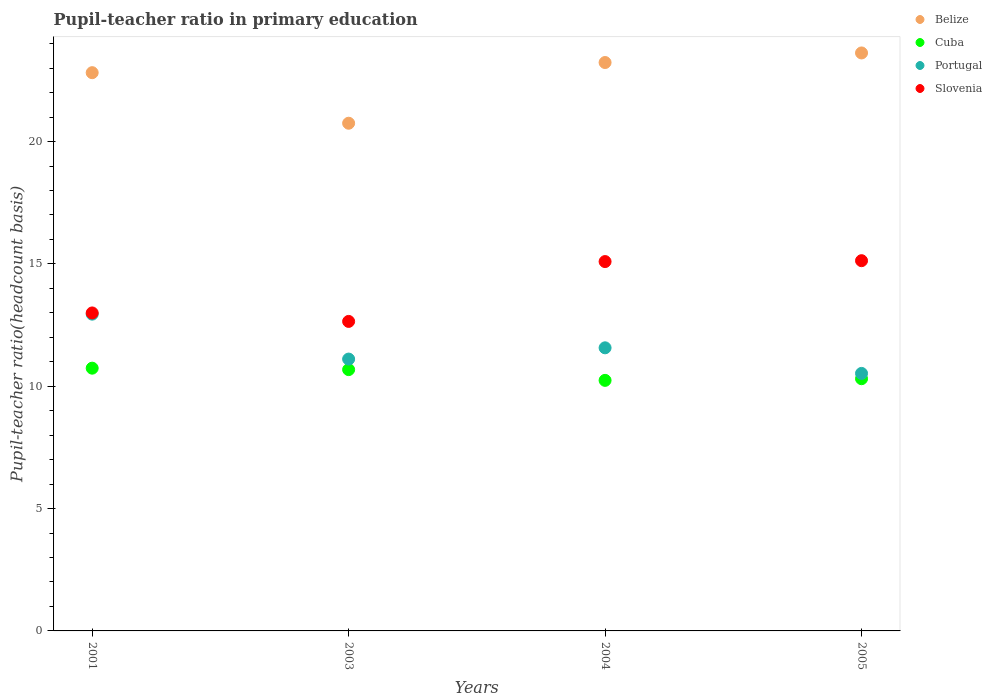How many different coloured dotlines are there?
Give a very brief answer. 4. Is the number of dotlines equal to the number of legend labels?
Keep it short and to the point. Yes. What is the pupil-teacher ratio in primary education in Belize in 2004?
Your answer should be very brief. 23.23. Across all years, what is the maximum pupil-teacher ratio in primary education in Slovenia?
Provide a short and direct response. 15.13. Across all years, what is the minimum pupil-teacher ratio in primary education in Belize?
Keep it short and to the point. 20.75. In which year was the pupil-teacher ratio in primary education in Belize minimum?
Provide a succinct answer. 2003. What is the total pupil-teacher ratio in primary education in Cuba in the graph?
Ensure brevity in your answer.  41.97. What is the difference between the pupil-teacher ratio in primary education in Slovenia in 2001 and that in 2005?
Give a very brief answer. -2.14. What is the difference between the pupil-teacher ratio in primary education in Slovenia in 2004 and the pupil-teacher ratio in primary education in Portugal in 2003?
Make the answer very short. 3.99. What is the average pupil-teacher ratio in primary education in Slovenia per year?
Your answer should be compact. 13.97. In the year 2005, what is the difference between the pupil-teacher ratio in primary education in Belize and pupil-teacher ratio in primary education in Cuba?
Make the answer very short. 13.32. In how many years, is the pupil-teacher ratio in primary education in Portugal greater than 8?
Offer a terse response. 4. What is the ratio of the pupil-teacher ratio in primary education in Cuba in 2003 to that in 2005?
Your response must be concise. 1.04. Is the pupil-teacher ratio in primary education in Belize in 2001 less than that in 2003?
Make the answer very short. No. Is the difference between the pupil-teacher ratio in primary education in Belize in 2001 and 2005 greater than the difference between the pupil-teacher ratio in primary education in Cuba in 2001 and 2005?
Provide a short and direct response. No. What is the difference between the highest and the second highest pupil-teacher ratio in primary education in Portugal?
Your response must be concise. 1.38. What is the difference between the highest and the lowest pupil-teacher ratio in primary education in Slovenia?
Provide a short and direct response. 2.48. In how many years, is the pupil-teacher ratio in primary education in Portugal greater than the average pupil-teacher ratio in primary education in Portugal taken over all years?
Your answer should be compact. 2. Is the sum of the pupil-teacher ratio in primary education in Belize in 2001 and 2005 greater than the maximum pupil-teacher ratio in primary education in Portugal across all years?
Your response must be concise. Yes. Is it the case that in every year, the sum of the pupil-teacher ratio in primary education in Cuba and pupil-teacher ratio in primary education in Belize  is greater than the sum of pupil-teacher ratio in primary education in Portugal and pupil-teacher ratio in primary education in Slovenia?
Provide a short and direct response. Yes. Is it the case that in every year, the sum of the pupil-teacher ratio in primary education in Slovenia and pupil-teacher ratio in primary education in Cuba  is greater than the pupil-teacher ratio in primary education in Belize?
Provide a short and direct response. Yes. Does the pupil-teacher ratio in primary education in Portugal monotonically increase over the years?
Your response must be concise. No. How many dotlines are there?
Provide a short and direct response. 4. Does the graph contain grids?
Your answer should be compact. No. Where does the legend appear in the graph?
Offer a terse response. Top right. What is the title of the graph?
Offer a very short reply. Pupil-teacher ratio in primary education. Does "Middle income" appear as one of the legend labels in the graph?
Keep it short and to the point. No. What is the label or title of the Y-axis?
Ensure brevity in your answer.  Pupil-teacher ratio(headcount basis). What is the Pupil-teacher ratio(headcount basis) of Belize in 2001?
Give a very brief answer. 22.82. What is the Pupil-teacher ratio(headcount basis) in Cuba in 2001?
Offer a terse response. 10.74. What is the Pupil-teacher ratio(headcount basis) in Portugal in 2001?
Give a very brief answer. 12.95. What is the Pupil-teacher ratio(headcount basis) of Slovenia in 2001?
Provide a short and direct response. 13. What is the Pupil-teacher ratio(headcount basis) in Belize in 2003?
Offer a terse response. 20.75. What is the Pupil-teacher ratio(headcount basis) in Cuba in 2003?
Offer a very short reply. 10.68. What is the Pupil-teacher ratio(headcount basis) of Portugal in 2003?
Your answer should be very brief. 11.11. What is the Pupil-teacher ratio(headcount basis) of Slovenia in 2003?
Your response must be concise. 12.65. What is the Pupil-teacher ratio(headcount basis) in Belize in 2004?
Ensure brevity in your answer.  23.23. What is the Pupil-teacher ratio(headcount basis) of Cuba in 2004?
Provide a short and direct response. 10.24. What is the Pupil-teacher ratio(headcount basis) in Portugal in 2004?
Your response must be concise. 11.57. What is the Pupil-teacher ratio(headcount basis) of Slovenia in 2004?
Offer a terse response. 15.1. What is the Pupil-teacher ratio(headcount basis) in Belize in 2005?
Offer a very short reply. 23.62. What is the Pupil-teacher ratio(headcount basis) in Cuba in 2005?
Your answer should be very brief. 10.31. What is the Pupil-teacher ratio(headcount basis) of Portugal in 2005?
Offer a very short reply. 10.53. What is the Pupil-teacher ratio(headcount basis) in Slovenia in 2005?
Your response must be concise. 15.13. Across all years, what is the maximum Pupil-teacher ratio(headcount basis) in Belize?
Ensure brevity in your answer.  23.62. Across all years, what is the maximum Pupil-teacher ratio(headcount basis) of Cuba?
Your answer should be compact. 10.74. Across all years, what is the maximum Pupil-teacher ratio(headcount basis) in Portugal?
Your answer should be compact. 12.95. Across all years, what is the maximum Pupil-teacher ratio(headcount basis) in Slovenia?
Ensure brevity in your answer.  15.13. Across all years, what is the minimum Pupil-teacher ratio(headcount basis) of Belize?
Your answer should be compact. 20.75. Across all years, what is the minimum Pupil-teacher ratio(headcount basis) of Cuba?
Provide a succinct answer. 10.24. Across all years, what is the minimum Pupil-teacher ratio(headcount basis) in Portugal?
Keep it short and to the point. 10.53. Across all years, what is the minimum Pupil-teacher ratio(headcount basis) in Slovenia?
Provide a succinct answer. 12.65. What is the total Pupil-teacher ratio(headcount basis) in Belize in the graph?
Ensure brevity in your answer.  90.42. What is the total Pupil-teacher ratio(headcount basis) in Cuba in the graph?
Offer a very short reply. 41.97. What is the total Pupil-teacher ratio(headcount basis) in Portugal in the graph?
Your answer should be compact. 46.15. What is the total Pupil-teacher ratio(headcount basis) of Slovenia in the graph?
Keep it short and to the point. 55.88. What is the difference between the Pupil-teacher ratio(headcount basis) in Belize in 2001 and that in 2003?
Provide a short and direct response. 2.07. What is the difference between the Pupil-teacher ratio(headcount basis) of Cuba in 2001 and that in 2003?
Keep it short and to the point. 0.06. What is the difference between the Pupil-teacher ratio(headcount basis) of Portugal in 2001 and that in 2003?
Keep it short and to the point. 1.84. What is the difference between the Pupil-teacher ratio(headcount basis) in Slovenia in 2001 and that in 2003?
Your answer should be compact. 0.35. What is the difference between the Pupil-teacher ratio(headcount basis) in Belize in 2001 and that in 2004?
Your answer should be very brief. -0.41. What is the difference between the Pupil-teacher ratio(headcount basis) of Cuba in 2001 and that in 2004?
Offer a very short reply. 0.5. What is the difference between the Pupil-teacher ratio(headcount basis) of Portugal in 2001 and that in 2004?
Offer a terse response. 1.38. What is the difference between the Pupil-teacher ratio(headcount basis) in Slovenia in 2001 and that in 2004?
Make the answer very short. -2.1. What is the difference between the Pupil-teacher ratio(headcount basis) of Belize in 2001 and that in 2005?
Ensure brevity in your answer.  -0.81. What is the difference between the Pupil-teacher ratio(headcount basis) of Cuba in 2001 and that in 2005?
Your response must be concise. 0.43. What is the difference between the Pupil-teacher ratio(headcount basis) of Portugal in 2001 and that in 2005?
Offer a terse response. 2.42. What is the difference between the Pupil-teacher ratio(headcount basis) in Slovenia in 2001 and that in 2005?
Provide a short and direct response. -2.14. What is the difference between the Pupil-teacher ratio(headcount basis) of Belize in 2003 and that in 2004?
Your answer should be very brief. -2.48. What is the difference between the Pupil-teacher ratio(headcount basis) in Cuba in 2003 and that in 2004?
Provide a short and direct response. 0.44. What is the difference between the Pupil-teacher ratio(headcount basis) in Portugal in 2003 and that in 2004?
Your answer should be very brief. -0.46. What is the difference between the Pupil-teacher ratio(headcount basis) of Slovenia in 2003 and that in 2004?
Offer a very short reply. -2.45. What is the difference between the Pupil-teacher ratio(headcount basis) in Belize in 2003 and that in 2005?
Give a very brief answer. -2.87. What is the difference between the Pupil-teacher ratio(headcount basis) in Cuba in 2003 and that in 2005?
Offer a terse response. 0.37. What is the difference between the Pupil-teacher ratio(headcount basis) of Portugal in 2003 and that in 2005?
Provide a succinct answer. 0.59. What is the difference between the Pupil-teacher ratio(headcount basis) in Slovenia in 2003 and that in 2005?
Give a very brief answer. -2.48. What is the difference between the Pupil-teacher ratio(headcount basis) of Belize in 2004 and that in 2005?
Provide a succinct answer. -0.39. What is the difference between the Pupil-teacher ratio(headcount basis) of Cuba in 2004 and that in 2005?
Your answer should be very brief. -0.07. What is the difference between the Pupil-teacher ratio(headcount basis) in Portugal in 2004 and that in 2005?
Offer a very short reply. 1.05. What is the difference between the Pupil-teacher ratio(headcount basis) of Slovenia in 2004 and that in 2005?
Offer a very short reply. -0.04. What is the difference between the Pupil-teacher ratio(headcount basis) in Belize in 2001 and the Pupil-teacher ratio(headcount basis) in Cuba in 2003?
Make the answer very short. 12.14. What is the difference between the Pupil-teacher ratio(headcount basis) in Belize in 2001 and the Pupil-teacher ratio(headcount basis) in Portugal in 2003?
Offer a very short reply. 11.71. What is the difference between the Pupil-teacher ratio(headcount basis) in Belize in 2001 and the Pupil-teacher ratio(headcount basis) in Slovenia in 2003?
Give a very brief answer. 10.17. What is the difference between the Pupil-teacher ratio(headcount basis) of Cuba in 2001 and the Pupil-teacher ratio(headcount basis) of Portugal in 2003?
Your answer should be compact. -0.37. What is the difference between the Pupil-teacher ratio(headcount basis) in Cuba in 2001 and the Pupil-teacher ratio(headcount basis) in Slovenia in 2003?
Offer a very short reply. -1.91. What is the difference between the Pupil-teacher ratio(headcount basis) of Portugal in 2001 and the Pupil-teacher ratio(headcount basis) of Slovenia in 2003?
Keep it short and to the point. 0.3. What is the difference between the Pupil-teacher ratio(headcount basis) in Belize in 2001 and the Pupil-teacher ratio(headcount basis) in Cuba in 2004?
Provide a short and direct response. 12.58. What is the difference between the Pupil-teacher ratio(headcount basis) in Belize in 2001 and the Pupil-teacher ratio(headcount basis) in Portugal in 2004?
Offer a very short reply. 11.25. What is the difference between the Pupil-teacher ratio(headcount basis) in Belize in 2001 and the Pupil-teacher ratio(headcount basis) in Slovenia in 2004?
Provide a short and direct response. 7.72. What is the difference between the Pupil-teacher ratio(headcount basis) of Cuba in 2001 and the Pupil-teacher ratio(headcount basis) of Portugal in 2004?
Your response must be concise. -0.83. What is the difference between the Pupil-teacher ratio(headcount basis) in Cuba in 2001 and the Pupil-teacher ratio(headcount basis) in Slovenia in 2004?
Your answer should be compact. -4.36. What is the difference between the Pupil-teacher ratio(headcount basis) of Portugal in 2001 and the Pupil-teacher ratio(headcount basis) of Slovenia in 2004?
Provide a succinct answer. -2.15. What is the difference between the Pupil-teacher ratio(headcount basis) in Belize in 2001 and the Pupil-teacher ratio(headcount basis) in Cuba in 2005?
Make the answer very short. 12.51. What is the difference between the Pupil-teacher ratio(headcount basis) of Belize in 2001 and the Pupil-teacher ratio(headcount basis) of Portugal in 2005?
Give a very brief answer. 12.29. What is the difference between the Pupil-teacher ratio(headcount basis) in Belize in 2001 and the Pupil-teacher ratio(headcount basis) in Slovenia in 2005?
Offer a terse response. 7.68. What is the difference between the Pupil-teacher ratio(headcount basis) of Cuba in 2001 and the Pupil-teacher ratio(headcount basis) of Portugal in 2005?
Give a very brief answer. 0.21. What is the difference between the Pupil-teacher ratio(headcount basis) in Cuba in 2001 and the Pupil-teacher ratio(headcount basis) in Slovenia in 2005?
Provide a short and direct response. -4.39. What is the difference between the Pupil-teacher ratio(headcount basis) of Portugal in 2001 and the Pupil-teacher ratio(headcount basis) of Slovenia in 2005?
Give a very brief answer. -2.19. What is the difference between the Pupil-teacher ratio(headcount basis) of Belize in 2003 and the Pupil-teacher ratio(headcount basis) of Cuba in 2004?
Offer a very short reply. 10.51. What is the difference between the Pupil-teacher ratio(headcount basis) of Belize in 2003 and the Pupil-teacher ratio(headcount basis) of Portugal in 2004?
Offer a terse response. 9.18. What is the difference between the Pupil-teacher ratio(headcount basis) of Belize in 2003 and the Pupil-teacher ratio(headcount basis) of Slovenia in 2004?
Keep it short and to the point. 5.65. What is the difference between the Pupil-teacher ratio(headcount basis) of Cuba in 2003 and the Pupil-teacher ratio(headcount basis) of Portugal in 2004?
Make the answer very short. -0.89. What is the difference between the Pupil-teacher ratio(headcount basis) of Cuba in 2003 and the Pupil-teacher ratio(headcount basis) of Slovenia in 2004?
Ensure brevity in your answer.  -4.42. What is the difference between the Pupil-teacher ratio(headcount basis) in Portugal in 2003 and the Pupil-teacher ratio(headcount basis) in Slovenia in 2004?
Offer a very short reply. -3.99. What is the difference between the Pupil-teacher ratio(headcount basis) of Belize in 2003 and the Pupil-teacher ratio(headcount basis) of Cuba in 2005?
Give a very brief answer. 10.44. What is the difference between the Pupil-teacher ratio(headcount basis) of Belize in 2003 and the Pupil-teacher ratio(headcount basis) of Portugal in 2005?
Ensure brevity in your answer.  10.23. What is the difference between the Pupil-teacher ratio(headcount basis) of Belize in 2003 and the Pupil-teacher ratio(headcount basis) of Slovenia in 2005?
Your answer should be compact. 5.62. What is the difference between the Pupil-teacher ratio(headcount basis) of Cuba in 2003 and the Pupil-teacher ratio(headcount basis) of Portugal in 2005?
Offer a terse response. 0.16. What is the difference between the Pupil-teacher ratio(headcount basis) of Cuba in 2003 and the Pupil-teacher ratio(headcount basis) of Slovenia in 2005?
Ensure brevity in your answer.  -4.45. What is the difference between the Pupil-teacher ratio(headcount basis) of Portugal in 2003 and the Pupil-teacher ratio(headcount basis) of Slovenia in 2005?
Make the answer very short. -4.02. What is the difference between the Pupil-teacher ratio(headcount basis) of Belize in 2004 and the Pupil-teacher ratio(headcount basis) of Cuba in 2005?
Keep it short and to the point. 12.92. What is the difference between the Pupil-teacher ratio(headcount basis) of Belize in 2004 and the Pupil-teacher ratio(headcount basis) of Portugal in 2005?
Provide a short and direct response. 12.71. What is the difference between the Pupil-teacher ratio(headcount basis) in Belize in 2004 and the Pupil-teacher ratio(headcount basis) in Slovenia in 2005?
Your answer should be very brief. 8.1. What is the difference between the Pupil-teacher ratio(headcount basis) in Cuba in 2004 and the Pupil-teacher ratio(headcount basis) in Portugal in 2005?
Offer a terse response. -0.28. What is the difference between the Pupil-teacher ratio(headcount basis) of Cuba in 2004 and the Pupil-teacher ratio(headcount basis) of Slovenia in 2005?
Your response must be concise. -4.89. What is the difference between the Pupil-teacher ratio(headcount basis) in Portugal in 2004 and the Pupil-teacher ratio(headcount basis) in Slovenia in 2005?
Offer a terse response. -3.56. What is the average Pupil-teacher ratio(headcount basis) in Belize per year?
Keep it short and to the point. 22.61. What is the average Pupil-teacher ratio(headcount basis) in Cuba per year?
Ensure brevity in your answer.  10.49. What is the average Pupil-teacher ratio(headcount basis) in Portugal per year?
Your answer should be compact. 11.54. What is the average Pupil-teacher ratio(headcount basis) of Slovenia per year?
Ensure brevity in your answer.  13.97. In the year 2001, what is the difference between the Pupil-teacher ratio(headcount basis) in Belize and Pupil-teacher ratio(headcount basis) in Cuba?
Make the answer very short. 12.08. In the year 2001, what is the difference between the Pupil-teacher ratio(headcount basis) in Belize and Pupil-teacher ratio(headcount basis) in Portugal?
Your answer should be compact. 9.87. In the year 2001, what is the difference between the Pupil-teacher ratio(headcount basis) of Belize and Pupil-teacher ratio(headcount basis) of Slovenia?
Offer a very short reply. 9.82. In the year 2001, what is the difference between the Pupil-teacher ratio(headcount basis) in Cuba and Pupil-teacher ratio(headcount basis) in Portugal?
Provide a short and direct response. -2.21. In the year 2001, what is the difference between the Pupil-teacher ratio(headcount basis) in Cuba and Pupil-teacher ratio(headcount basis) in Slovenia?
Provide a succinct answer. -2.26. In the year 2001, what is the difference between the Pupil-teacher ratio(headcount basis) of Portugal and Pupil-teacher ratio(headcount basis) of Slovenia?
Your response must be concise. -0.05. In the year 2003, what is the difference between the Pupil-teacher ratio(headcount basis) in Belize and Pupil-teacher ratio(headcount basis) in Cuba?
Make the answer very short. 10.07. In the year 2003, what is the difference between the Pupil-teacher ratio(headcount basis) of Belize and Pupil-teacher ratio(headcount basis) of Portugal?
Make the answer very short. 9.64. In the year 2003, what is the difference between the Pupil-teacher ratio(headcount basis) of Belize and Pupil-teacher ratio(headcount basis) of Slovenia?
Your response must be concise. 8.1. In the year 2003, what is the difference between the Pupil-teacher ratio(headcount basis) in Cuba and Pupil-teacher ratio(headcount basis) in Portugal?
Offer a very short reply. -0.43. In the year 2003, what is the difference between the Pupil-teacher ratio(headcount basis) of Cuba and Pupil-teacher ratio(headcount basis) of Slovenia?
Your response must be concise. -1.97. In the year 2003, what is the difference between the Pupil-teacher ratio(headcount basis) in Portugal and Pupil-teacher ratio(headcount basis) in Slovenia?
Your answer should be compact. -1.54. In the year 2004, what is the difference between the Pupil-teacher ratio(headcount basis) of Belize and Pupil-teacher ratio(headcount basis) of Cuba?
Ensure brevity in your answer.  12.99. In the year 2004, what is the difference between the Pupil-teacher ratio(headcount basis) in Belize and Pupil-teacher ratio(headcount basis) in Portugal?
Keep it short and to the point. 11.66. In the year 2004, what is the difference between the Pupil-teacher ratio(headcount basis) in Belize and Pupil-teacher ratio(headcount basis) in Slovenia?
Your answer should be compact. 8.14. In the year 2004, what is the difference between the Pupil-teacher ratio(headcount basis) of Cuba and Pupil-teacher ratio(headcount basis) of Portugal?
Your response must be concise. -1.33. In the year 2004, what is the difference between the Pupil-teacher ratio(headcount basis) of Cuba and Pupil-teacher ratio(headcount basis) of Slovenia?
Provide a succinct answer. -4.86. In the year 2004, what is the difference between the Pupil-teacher ratio(headcount basis) in Portugal and Pupil-teacher ratio(headcount basis) in Slovenia?
Ensure brevity in your answer.  -3.53. In the year 2005, what is the difference between the Pupil-teacher ratio(headcount basis) in Belize and Pupil-teacher ratio(headcount basis) in Cuba?
Offer a very short reply. 13.31. In the year 2005, what is the difference between the Pupil-teacher ratio(headcount basis) of Belize and Pupil-teacher ratio(headcount basis) of Portugal?
Your answer should be compact. 13.1. In the year 2005, what is the difference between the Pupil-teacher ratio(headcount basis) of Belize and Pupil-teacher ratio(headcount basis) of Slovenia?
Keep it short and to the point. 8.49. In the year 2005, what is the difference between the Pupil-teacher ratio(headcount basis) in Cuba and Pupil-teacher ratio(headcount basis) in Portugal?
Ensure brevity in your answer.  -0.22. In the year 2005, what is the difference between the Pupil-teacher ratio(headcount basis) in Cuba and Pupil-teacher ratio(headcount basis) in Slovenia?
Keep it short and to the point. -4.82. In the year 2005, what is the difference between the Pupil-teacher ratio(headcount basis) of Portugal and Pupil-teacher ratio(headcount basis) of Slovenia?
Your answer should be very brief. -4.61. What is the ratio of the Pupil-teacher ratio(headcount basis) in Belize in 2001 to that in 2003?
Your answer should be very brief. 1.1. What is the ratio of the Pupil-teacher ratio(headcount basis) in Cuba in 2001 to that in 2003?
Offer a very short reply. 1.01. What is the ratio of the Pupil-teacher ratio(headcount basis) in Portugal in 2001 to that in 2003?
Your answer should be very brief. 1.17. What is the ratio of the Pupil-teacher ratio(headcount basis) of Slovenia in 2001 to that in 2003?
Your answer should be very brief. 1.03. What is the ratio of the Pupil-teacher ratio(headcount basis) in Belize in 2001 to that in 2004?
Offer a terse response. 0.98. What is the ratio of the Pupil-teacher ratio(headcount basis) of Cuba in 2001 to that in 2004?
Give a very brief answer. 1.05. What is the ratio of the Pupil-teacher ratio(headcount basis) in Portugal in 2001 to that in 2004?
Your response must be concise. 1.12. What is the ratio of the Pupil-teacher ratio(headcount basis) in Slovenia in 2001 to that in 2004?
Keep it short and to the point. 0.86. What is the ratio of the Pupil-teacher ratio(headcount basis) of Belize in 2001 to that in 2005?
Keep it short and to the point. 0.97. What is the ratio of the Pupil-teacher ratio(headcount basis) in Cuba in 2001 to that in 2005?
Your answer should be compact. 1.04. What is the ratio of the Pupil-teacher ratio(headcount basis) of Portugal in 2001 to that in 2005?
Keep it short and to the point. 1.23. What is the ratio of the Pupil-teacher ratio(headcount basis) in Slovenia in 2001 to that in 2005?
Your answer should be very brief. 0.86. What is the ratio of the Pupil-teacher ratio(headcount basis) of Belize in 2003 to that in 2004?
Provide a short and direct response. 0.89. What is the ratio of the Pupil-teacher ratio(headcount basis) in Cuba in 2003 to that in 2004?
Provide a succinct answer. 1.04. What is the ratio of the Pupil-teacher ratio(headcount basis) in Portugal in 2003 to that in 2004?
Your response must be concise. 0.96. What is the ratio of the Pupil-teacher ratio(headcount basis) in Slovenia in 2003 to that in 2004?
Give a very brief answer. 0.84. What is the ratio of the Pupil-teacher ratio(headcount basis) of Belize in 2003 to that in 2005?
Your answer should be very brief. 0.88. What is the ratio of the Pupil-teacher ratio(headcount basis) of Cuba in 2003 to that in 2005?
Your response must be concise. 1.04. What is the ratio of the Pupil-teacher ratio(headcount basis) of Portugal in 2003 to that in 2005?
Offer a terse response. 1.06. What is the ratio of the Pupil-teacher ratio(headcount basis) of Slovenia in 2003 to that in 2005?
Offer a terse response. 0.84. What is the ratio of the Pupil-teacher ratio(headcount basis) of Belize in 2004 to that in 2005?
Offer a terse response. 0.98. What is the ratio of the Pupil-teacher ratio(headcount basis) in Cuba in 2004 to that in 2005?
Provide a succinct answer. 0.99. What is the ratio of the Pupil-teacher ratio(headcount basis) in Portugal in 2004 to that in 2005?
Give a very brief answer. 1.1. What is the ratio of the Pupil-teacher ratio(headcount basis) of Slovenia in 2004 to that in 2005?
Your response must be concise. 1. What is the difference between the highest and the second highest Pupil-teacher ratio(headcount basis) of Belize?
Your response must be concise. 0.39. What is the difference between the highest and the second highest Pupil-teacher ratio(headcount basis) of Cuba?
Offer a very short reply. 0.06. What is the difference between the highest and the second highest Pupil-teacher ratio(headcount basis) in Portugal?
Give a very brief answer. 1.38. What is the difference between the highest and the second highest Pupil-teacher ratio(headcount basis) of Slovenia?
Give a very brief answer. 0.04. What is the difference between the highest and the lowest Pupil-teacher ratio(headcount basis) of Belize?
Provide a succinct answer. 2.87. What is the difference between the highest and the lowest Pupil-teacher ratio(headcount basis) in Cuba?
Your answer should be very brief. 0.5. What is the difference between the highest and the lowest Pupil-teacher ratio(headcount basis) of Portugal?
Make the answer very short. 2.42. What is the difference between the highest and the lowest Pupil-teacher ratio(headcount basis) in Slovenia?
Ensure brevity in your answer.  2.48. 